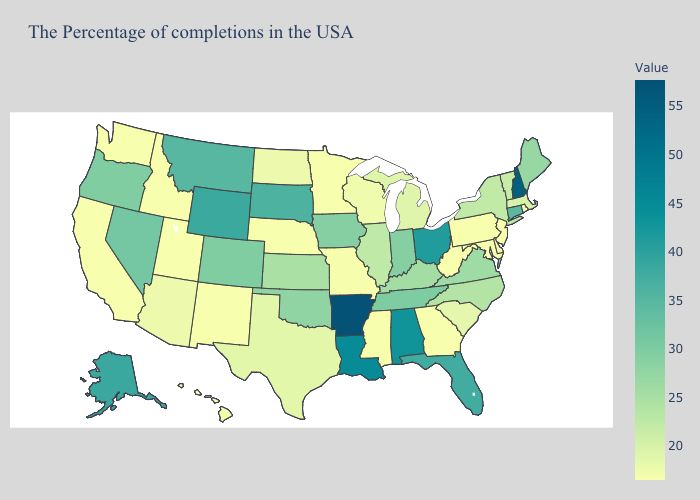Which states have the lowest value in the USA?
Answer briefly. Rhode Island, New Jersey, Delaware, Maryland, Pennsylvania, West Virginia, Georgia, Mississippi, Minnesota, Nebraska, New Mexico, Utah, Idaho, California, Washington, Hawaii. Which states hav the highest value in the South?
Short answer required. Arkansas. Is the legend a continuous bar?
Short answer required. Yes. Does Arkansas have the lowest value in the USA?
Quick response, please. No. Among the states that border California , which have the highest value?
Quick response, please. Nevada. 